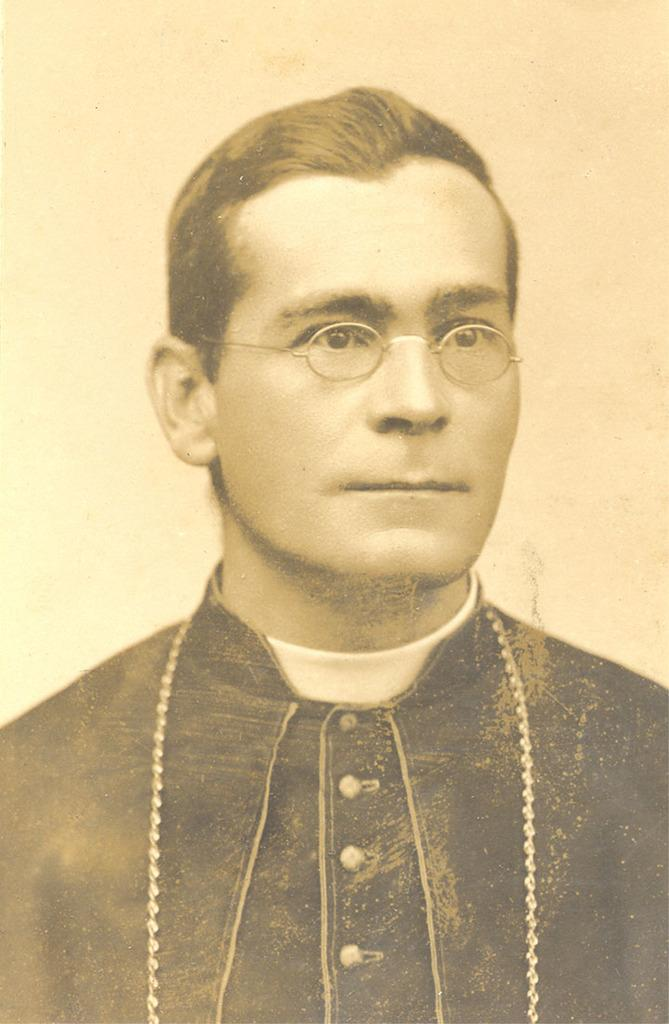Who or what is the main subject of the image? There is a person in the image. What can be observed about the person's appearance? The person is wearing spectacles. What is visible in the background of the image? There is a wall in the background of the image. What type of toad can be seen in the image? There is no toad present in the image; it features a person wearing spectacles with a wall in the background. 